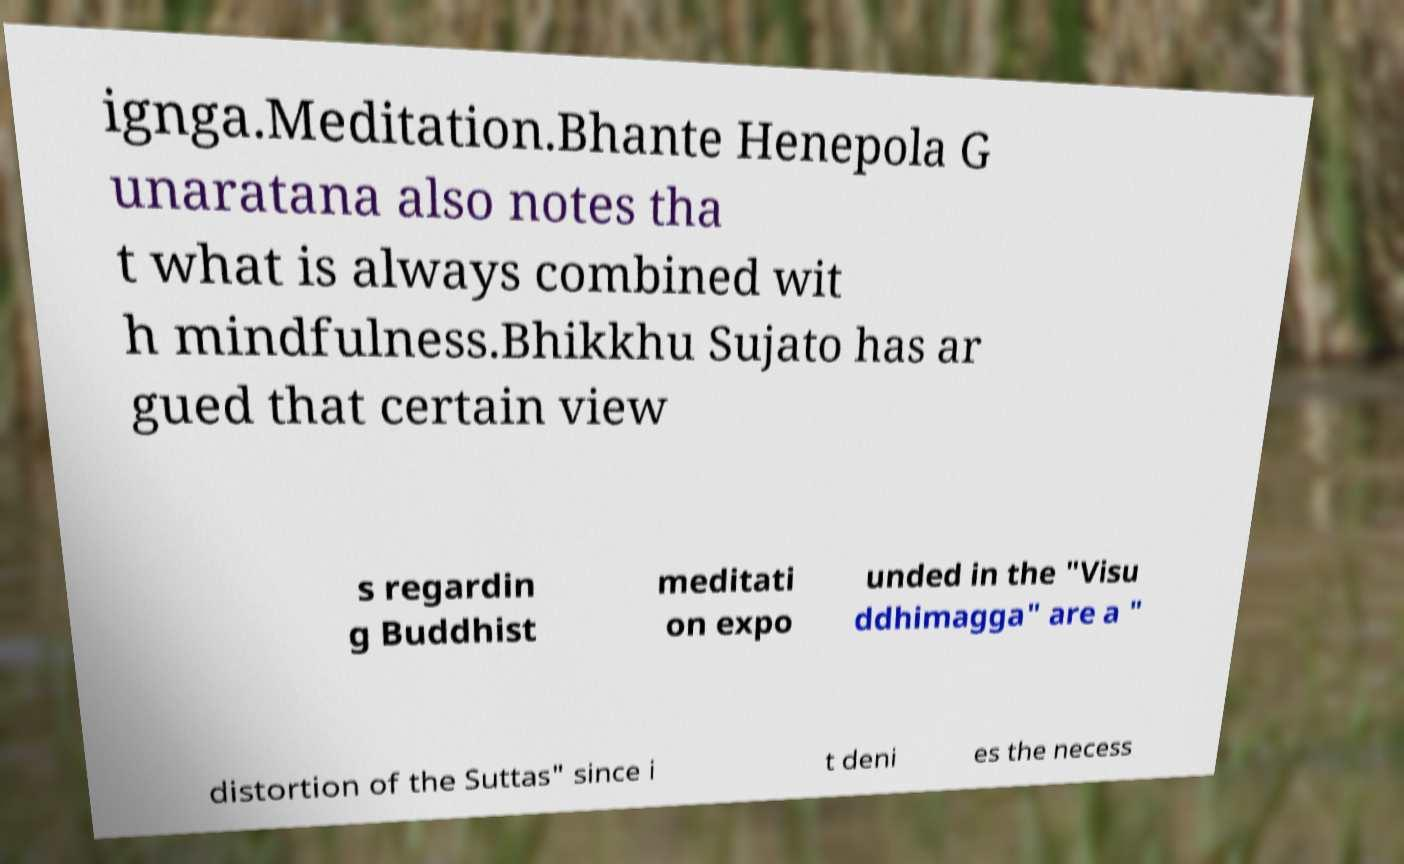Please read and relay the text visible in this image. What does it say? ignga.Meditation.Bhante Henepola G unaratana also notes tha t what is always combined wit h mindfulness.Bhikkhu Sujato has ar gued that certain view s regardin g Buddhist meditati on expo unded in the "Visu ddhimagga" are a " distortion of the Suttas" since i t deni es the necess 